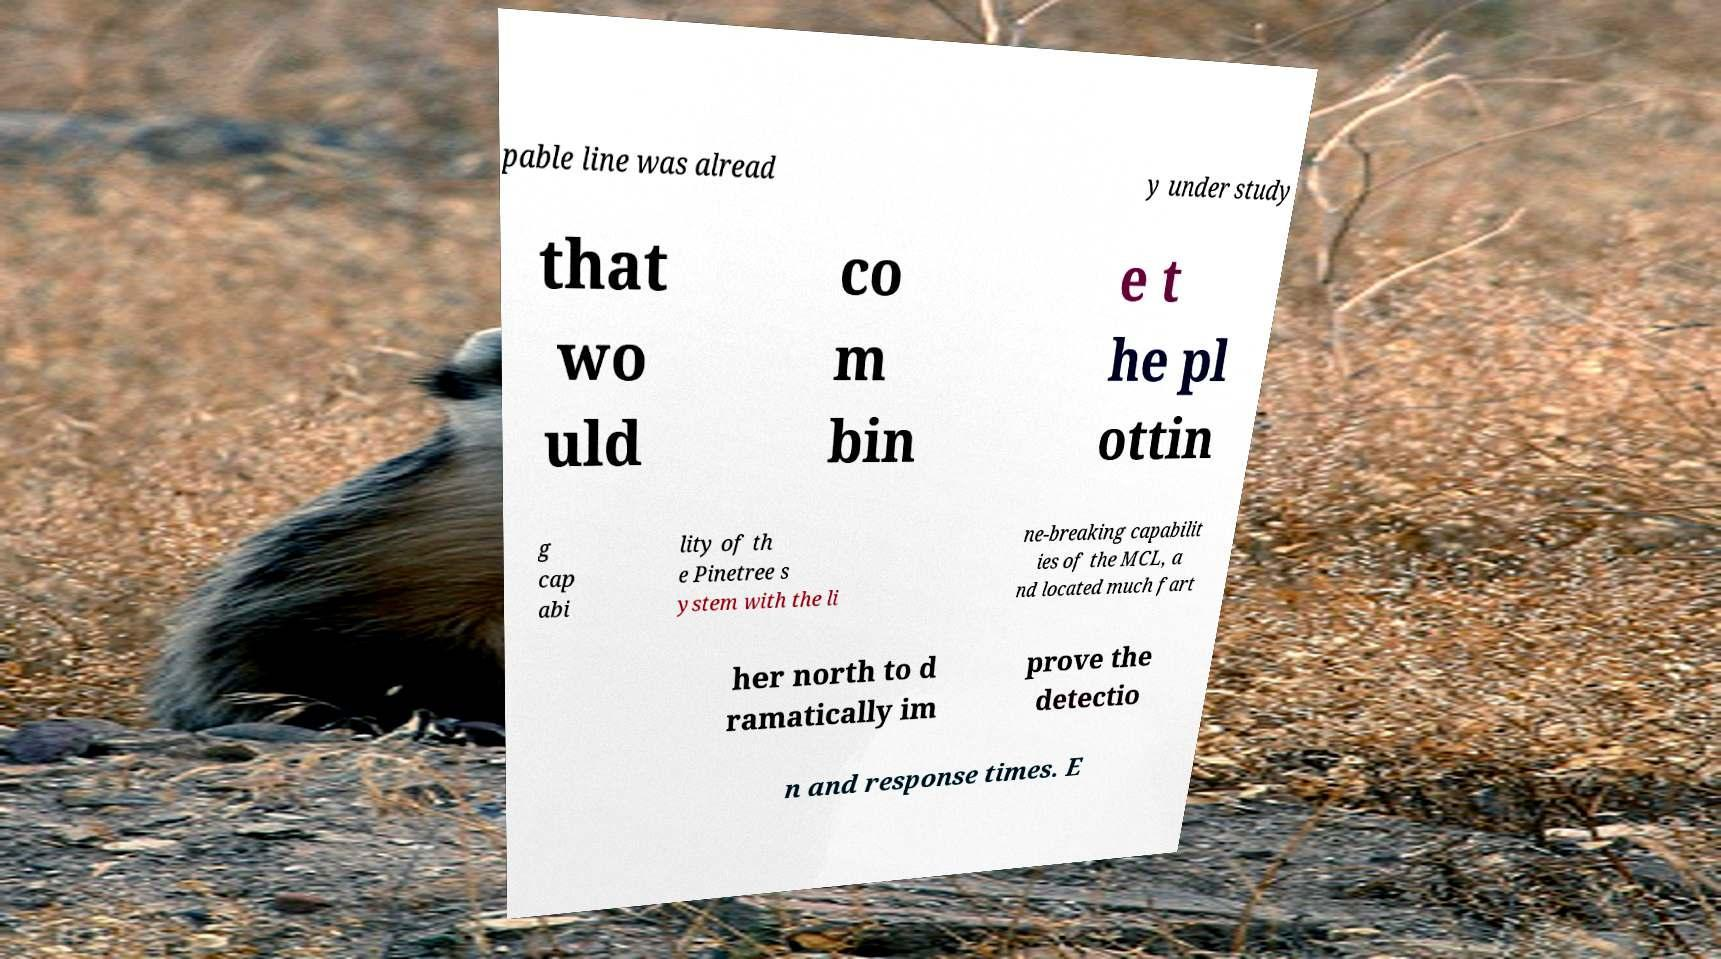I need the written content from this picture converted into text. Can you do that? pable line was alread y under study that wo uld co m bin e t he pl ottin g cap abi lity of th e Pinetree s ystem with the li ne-breaking capabilit ies of the MCL, a nd located much fart her north to d ramatically im prove the detectio n and response times. E 